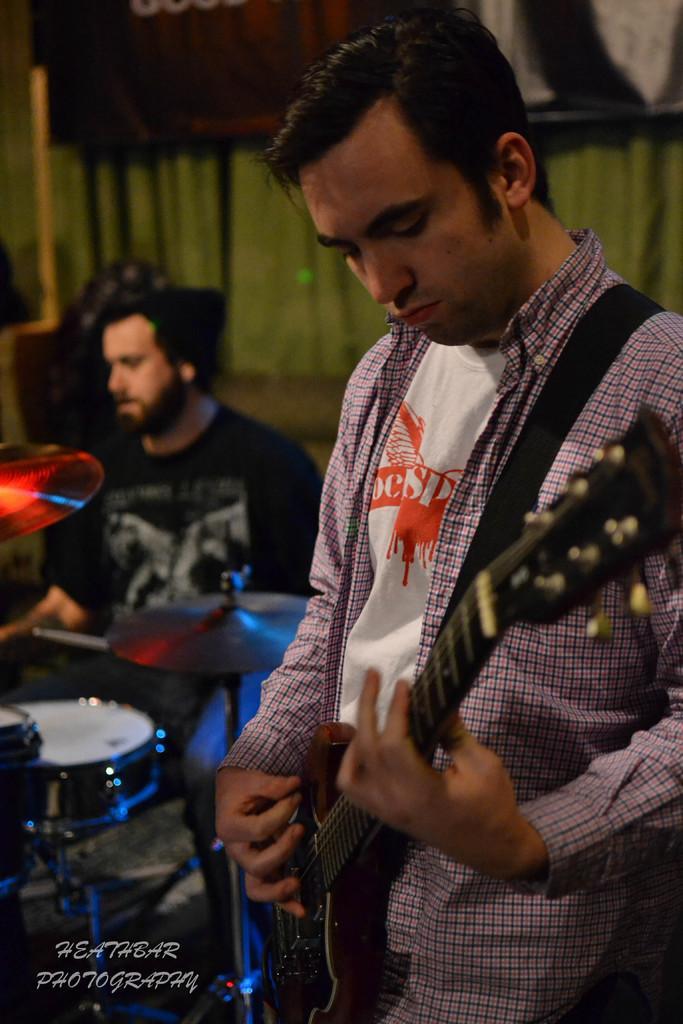Describe this image in one or two sentences. In this image, I can see the man standing and playing the guitar. Here is another person sitting and playing the drums. I think this is a hi-hat instrument. This is the watermark on the image. 